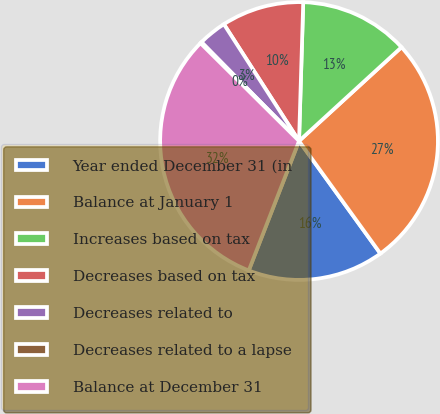Convert chart to OTSL. <chart><loc_0><loc_0><loc_500><loc_500><pie_chart><fcel>Year ended December 31 (in<fcel>Balance at January 1<fcel>Increases based on tax<fcel>Decreases based on tax<fcel>Decreases related to<fcel>Decreases related to a lapse<fcel>Balance at December 31<nl><fcel>15.86%<fcel>26.84%<fcel>12.72%<fcel>9.58%<fcel>3.3%<fcel>0.16%<fcel>31.55%<nl></chart> 